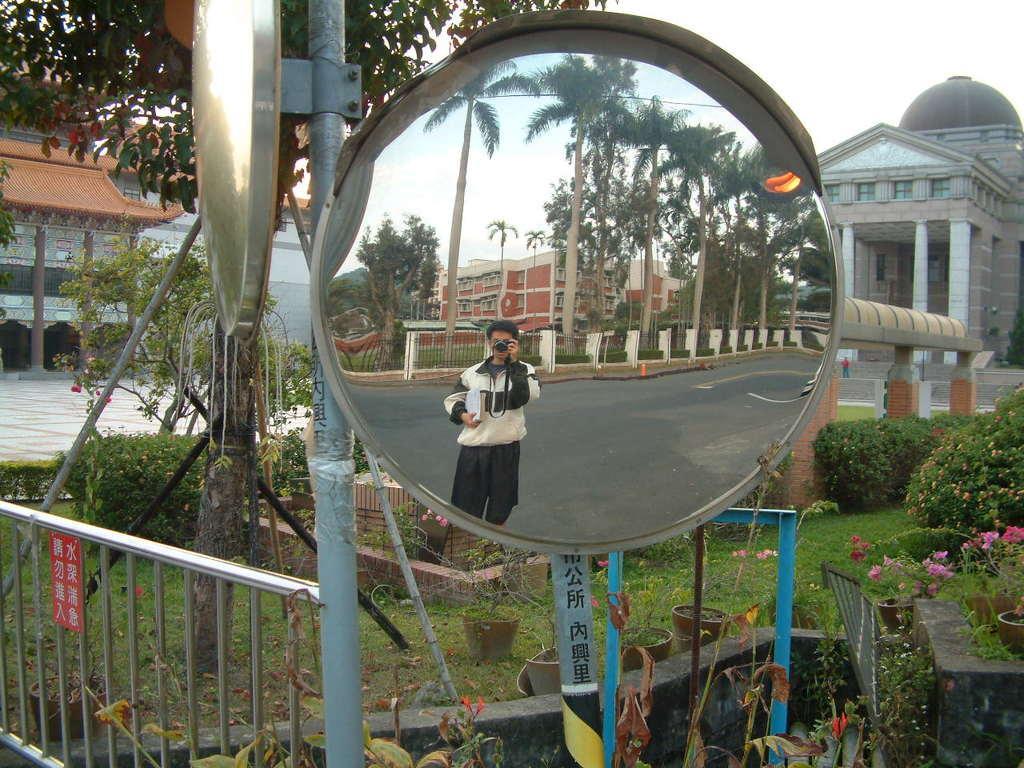Please provide a concise description of this image. In a mirror we can see the reflection of a building, trees, fence, road. We can see a man holding a camera. In the background we can see the sky, trees, buildings. Far we can see a person. We can see the railing, board, grass, flower pots and the plants. 